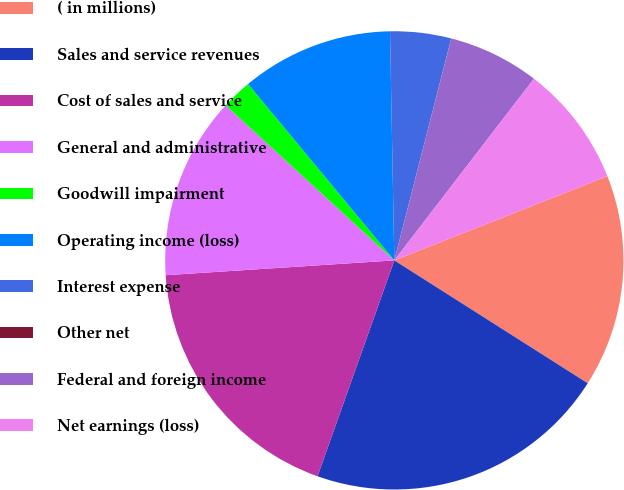Convert chart. <chart><loc_0><loc_0><loc_500><loc_500><pie_chart><fcel>( in millions)<fcel>Sales and service revenues<fcel>Cost of sales and service<fcel>General and administrative<fcel>Goodwill impairment<fcel>Operating income (loss)<fcel>Interest expense<fcel>Other net<fcel>Federal and foreign income<fcel>Net earnings (loss)<nl><fcel>15.0%<fcel>21.43%<fcel>18.53%<fcel>12.86%<fcel>2.15%<fcel>10.72%<fcel>4.29%<fcel>0.01%<fcel>6.43%<fcel>8.58%<nl></chart> 